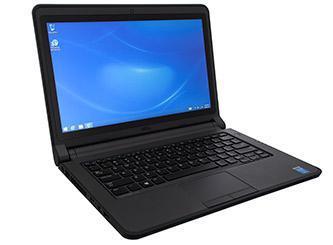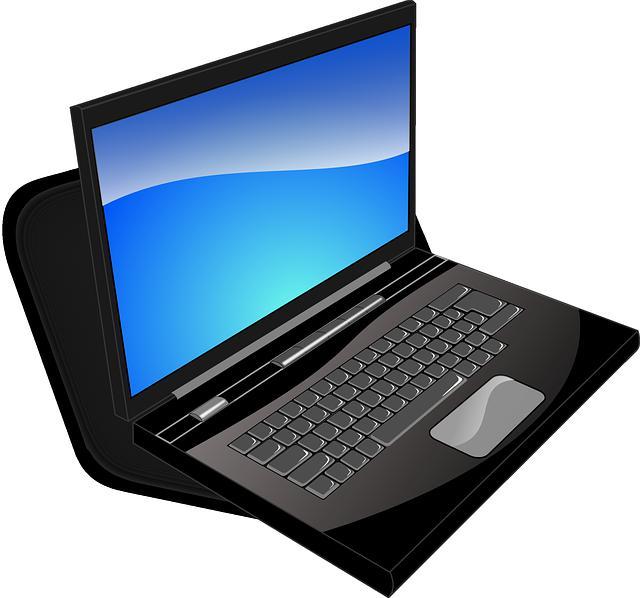The first image is the image on the left, the second image is the image on the right. For the images shown, is this caption "Each image shows one opened laptop angled so the screen faces rightward." true? Answer yes or no. Yes. The first image is the image on the left, the second image is the image on the right. For the images shown, is this caption "Both of the laptops are facing in the same direction." true? Answer yes or no. Yes. 